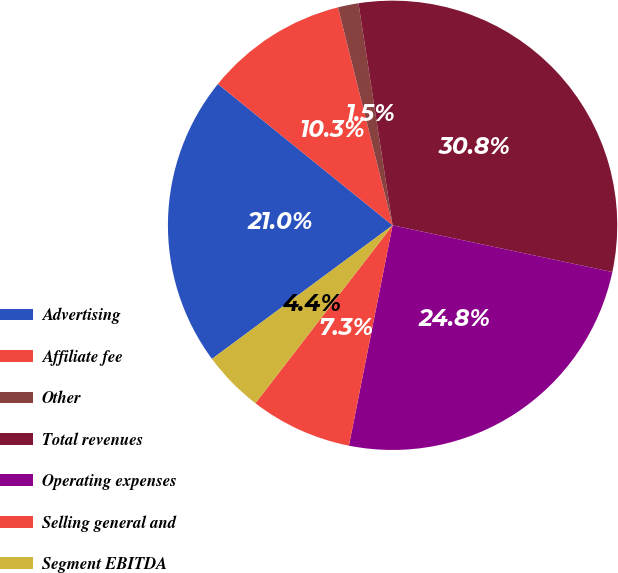Convert chart to OTSL. <chart><loc_0><loc_0><loc_500><loc_500><pie_chart><fcel>Advertising<fcel>Affiliate fee<fcel>Other<fcel>Total revenues<fcel>Operating expenses<fcel>Selling general and<fcel>Segment EBITDA<nl><fcel>20.96%<fcel>10.27%<fcel>1.48%<fcel>30.76%<fcel>24.78%<fcel>7.34%<fcel>4.41%<nl></chart> 